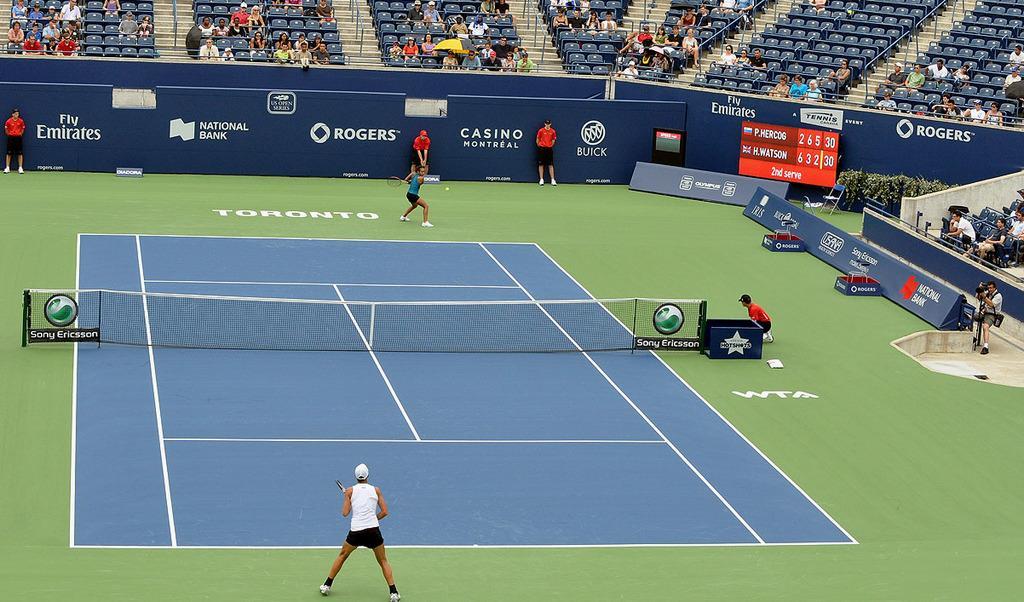Could you give a brief overview of what you see in this image? It is a badminton court where we can see two people playing in front of them there is a net and one umpire is there and one camera man is there. There are so many seats and people are there watching the game. Players are holding rackets in their hands. 